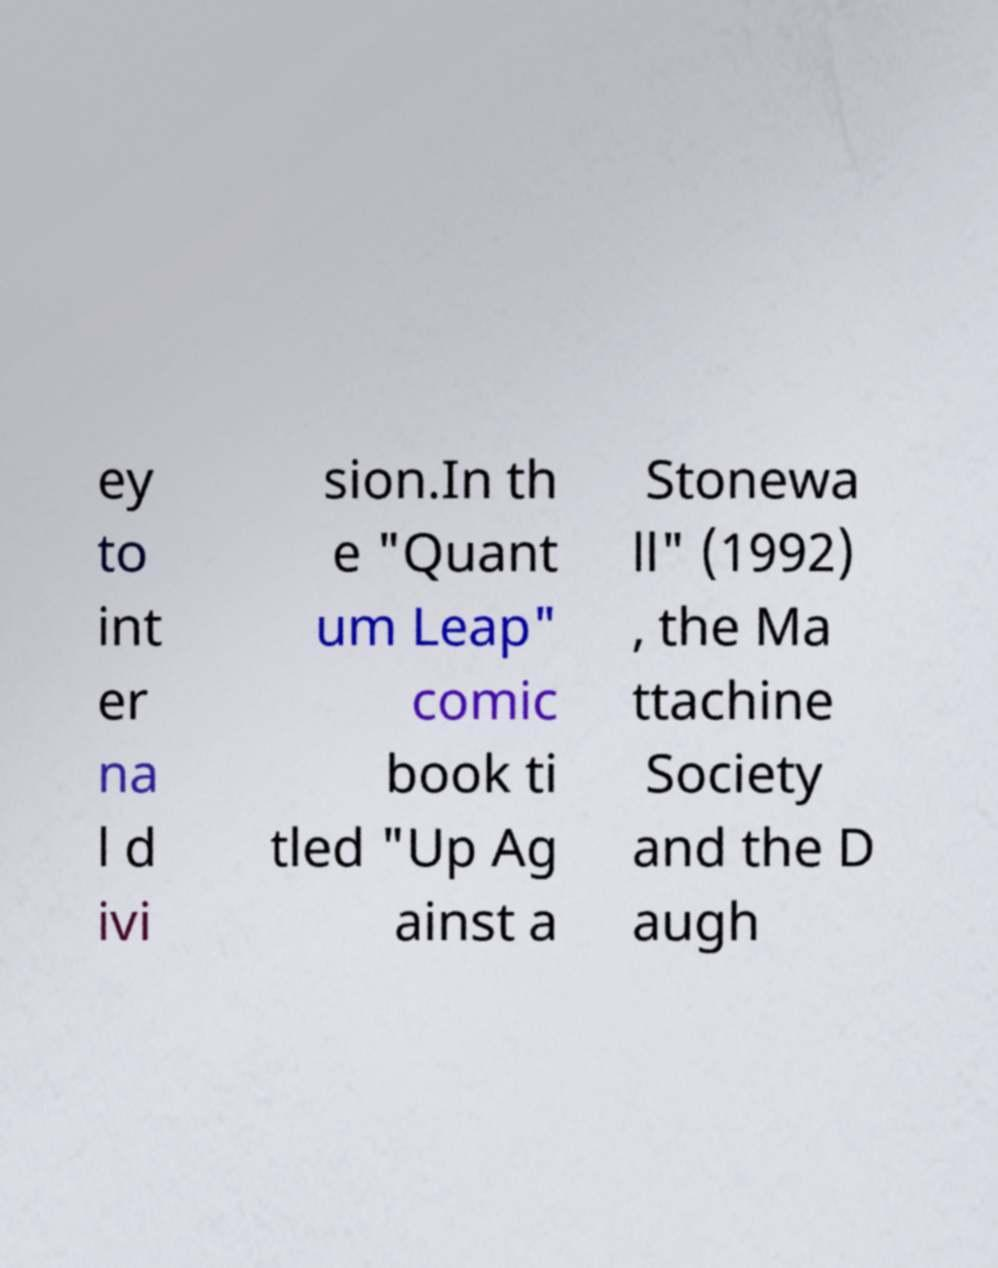What messages or text are displayed in this image? I need them in a readable, typed format. ey to int er na l d ivi sion.In th e "Quant um Leap" comic book ti tled "Up Ag ainst a Stonewa ll" (1992) , the Ma ttachine Society and the D augh 